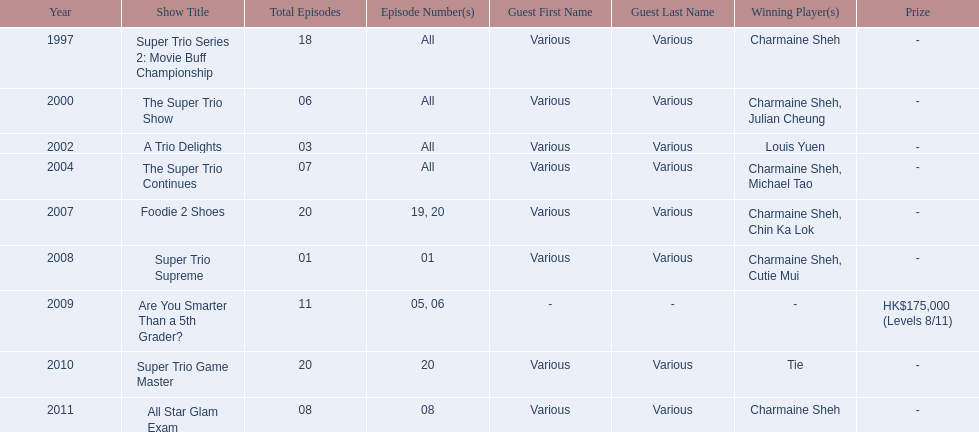Parse the table in full. {'header': ['Year', 'Show Title', 'Total Episodes', 'Episode Number(s)', 'Guest First Name', 'Guest Last Name', 'Winning Player(s)', 'Prize'], 'rows': [['1997', 'Super Trio Series 2: Movie Buff Championship', '18', 'All', 'Various', 'Various', 'Charmaine Sheh', '-'], ['2000', 'The Super Trio Show', '06', 'All', 'Various', 'Various', 'Charmaine Sheh, Julian Cheung', '-'], ['2002', 'A Trio Delights', '03', 'All', 'Various', 'Various', 'Louis Yuen', '-'], ['2004', 'The Super Trio Continues', '07', 'All', 'Various', 'Various', 'Charmaine Sheh, Michael Tao', '-'], ['2007', 'Foodie 2 Shoes', '20', '19, 20', 'Various', 'Various', 'Charmaine Sheh, Chin Ka Lok', '-'], ['2008', 'Super Trio Supreme', '01', '01', 'Various', 'Various', 'Charmaine Sheh, Cutie Mui', '-'], ['2009', 'Are You Smarter Than a 5th Grader?', '11', '05, 06', '-', '-', '-', 'HK$175,000 (Levels 8/11)'], ['2010', 'Super Trio Game Master', '20', '20', 'Various', 'Various', 'Tie', '-'], ['2011', 'All Star Glam Exam', '08', '08', 'Various', 'Various', 'Charmaine Sheh', '-']]} What year was the only year were a tie occurred? 2010. 